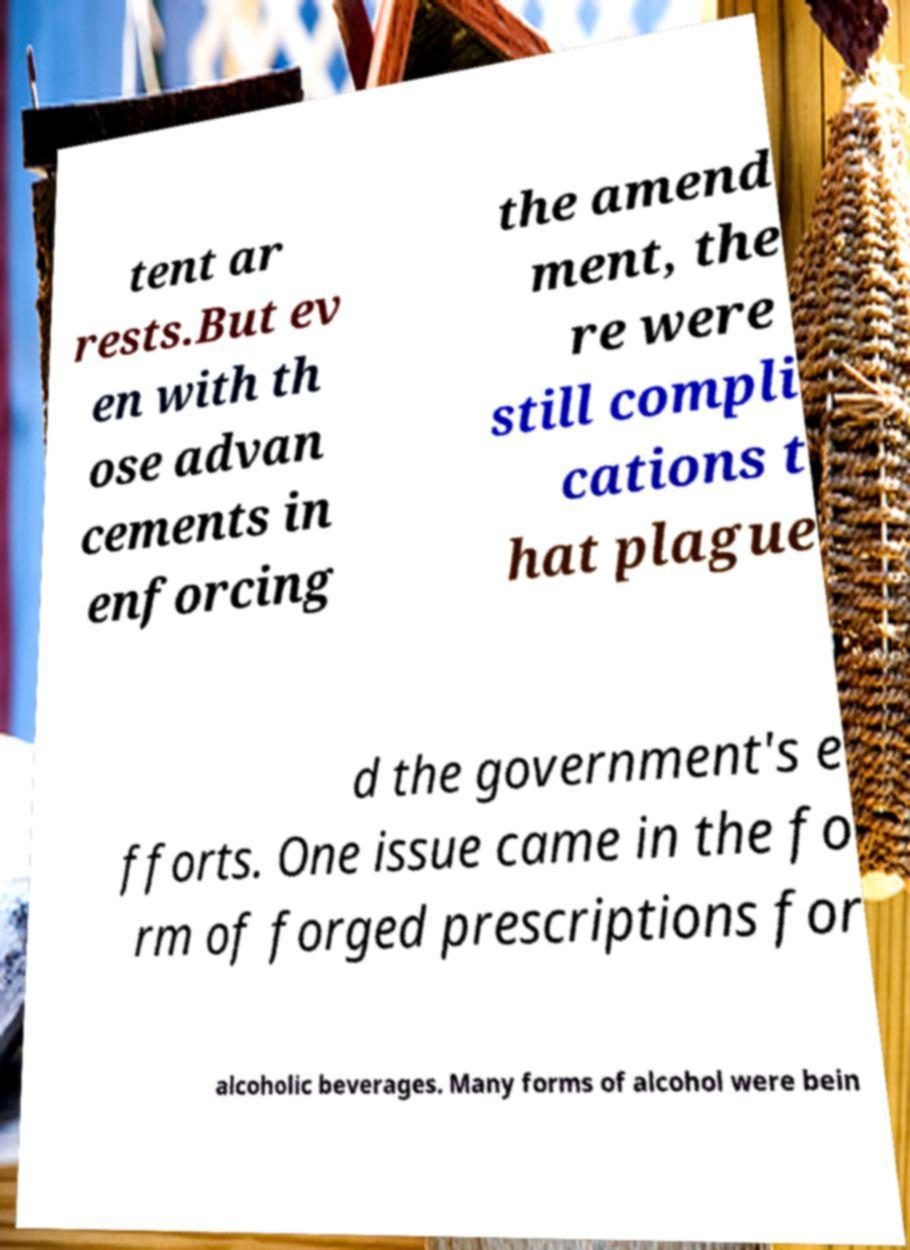Please identify and transcribe the text found in this image. tent ar rests.But ev en with th ose advan cements in enforcing the amend ment, the re were still compli cations t hat plague d the government's e fforts. One issue came in the fo rm of forged prescriptions for alcoholic beverages. Many forms of alcohol were bein 